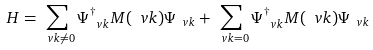Convert formula to latex. <formula><loc_0><loc_0><loc_500><loc_500>H = \sum _ { \ v { k } \neq 0 } \Psi _ { \ v { k } } ^ { \dag } M ( \ v { k } ) \Psi _ { \ v { k } } + \sum _ { \ v { k } = 0 } \Psi _ { \ v { k } } ^ { \dag } M ( \ v { k } ) \Psi _ { \ v { k } }</formula> 